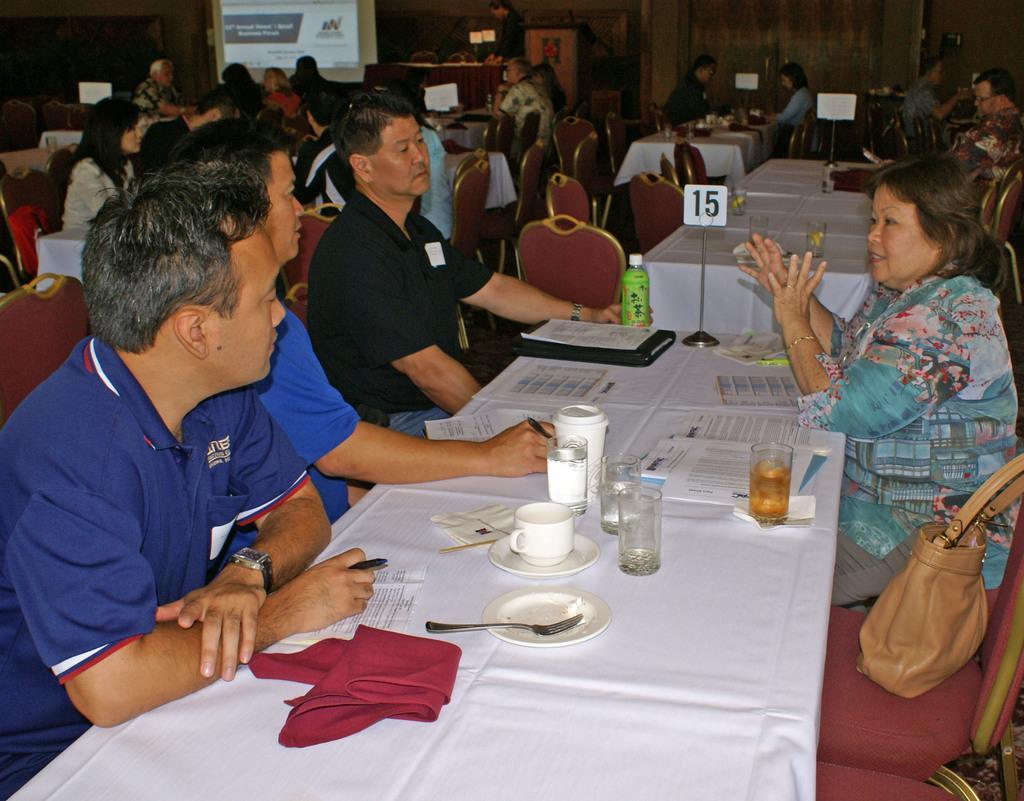Could you give a brief overview of what you see in this image? This picture describes about group of people few are seated on the chair and few are standing, in front of them we can find papers, glasses, cups, napkins and spoons on the table, in the right side of the given image we can find a bag besides to a woman and also we can find a projector screen in the background. 